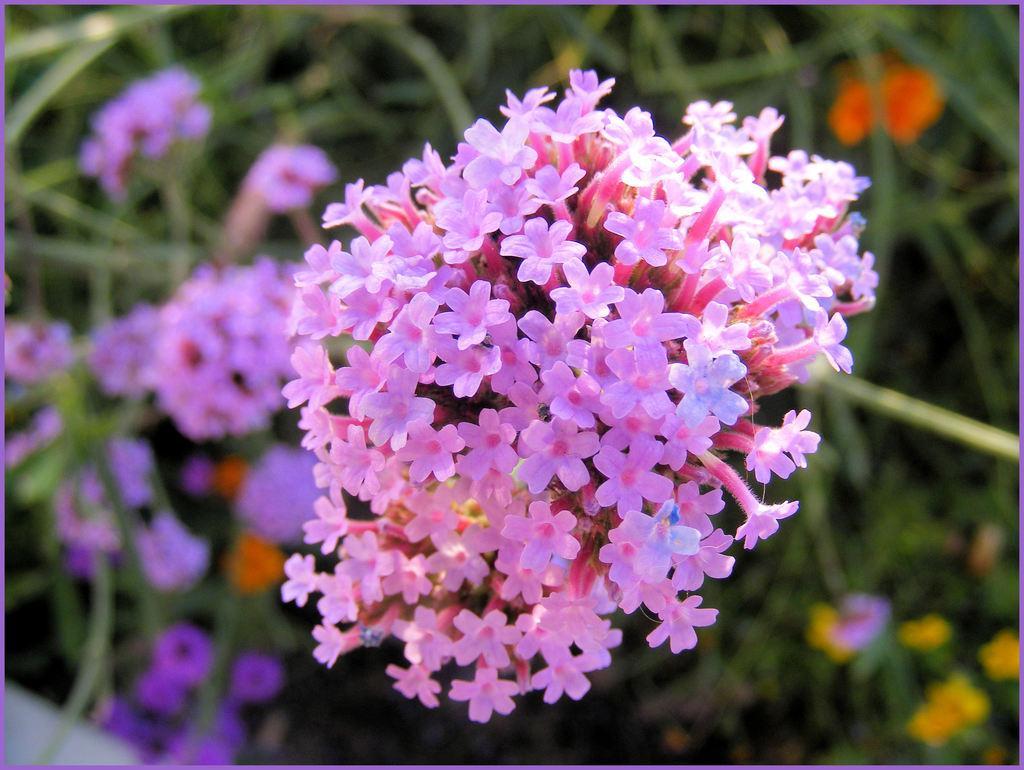Please provide a concise description of this image. In this picture, we can see plants, flowers, and the blurred background. 